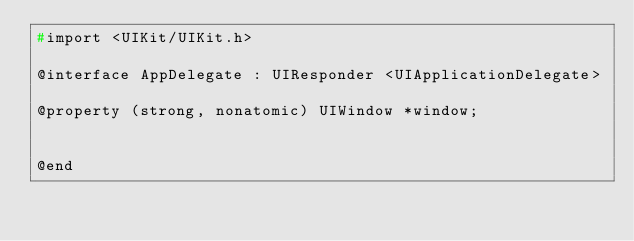<code> <loc_0><loc_0><loc_500><loc_500><_C_>#import <UIKit/UIKit.h>

@interface AppDelegate : UIResponder <UIApplicationDelegate>

@property (strong, nonatomic) UIWindow *window;


@end

</code> 